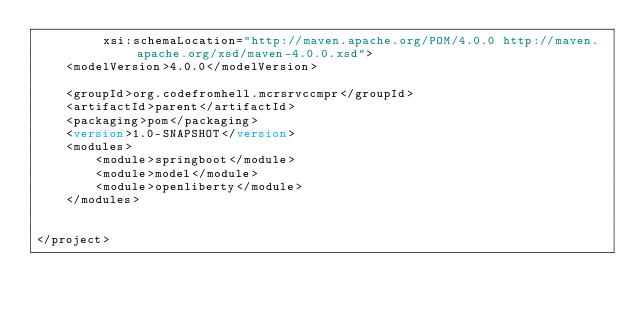<code> <loc_0><loc_0><loc_500><loc_500><_XML_>         xsi:schemaLocation="http://maven.apache.org/POM/4.0.0 http://maven.apache.org/xsd/maven-4.0.0.xsd">
    <modelVersion>4.0.0</modelVersion>

    <groupId>org.codefromhell.mcrsrvccmpr</groupId>
    <artifactId>parent</artifactId>
    <packaging>pom</packaging>
    <version>1.0-SNAPSHOT</version>
    <modules>
        <module>springboot</module>
        <module>model</module>
        <module>openliberty</module>
    </modules>


</project></code> 